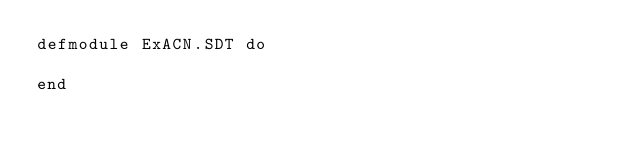<code> <loc_0><loc_0><loc_500><loc_500><_Elixir_>defmodule ExACN.SDT do
  
end
</code> 